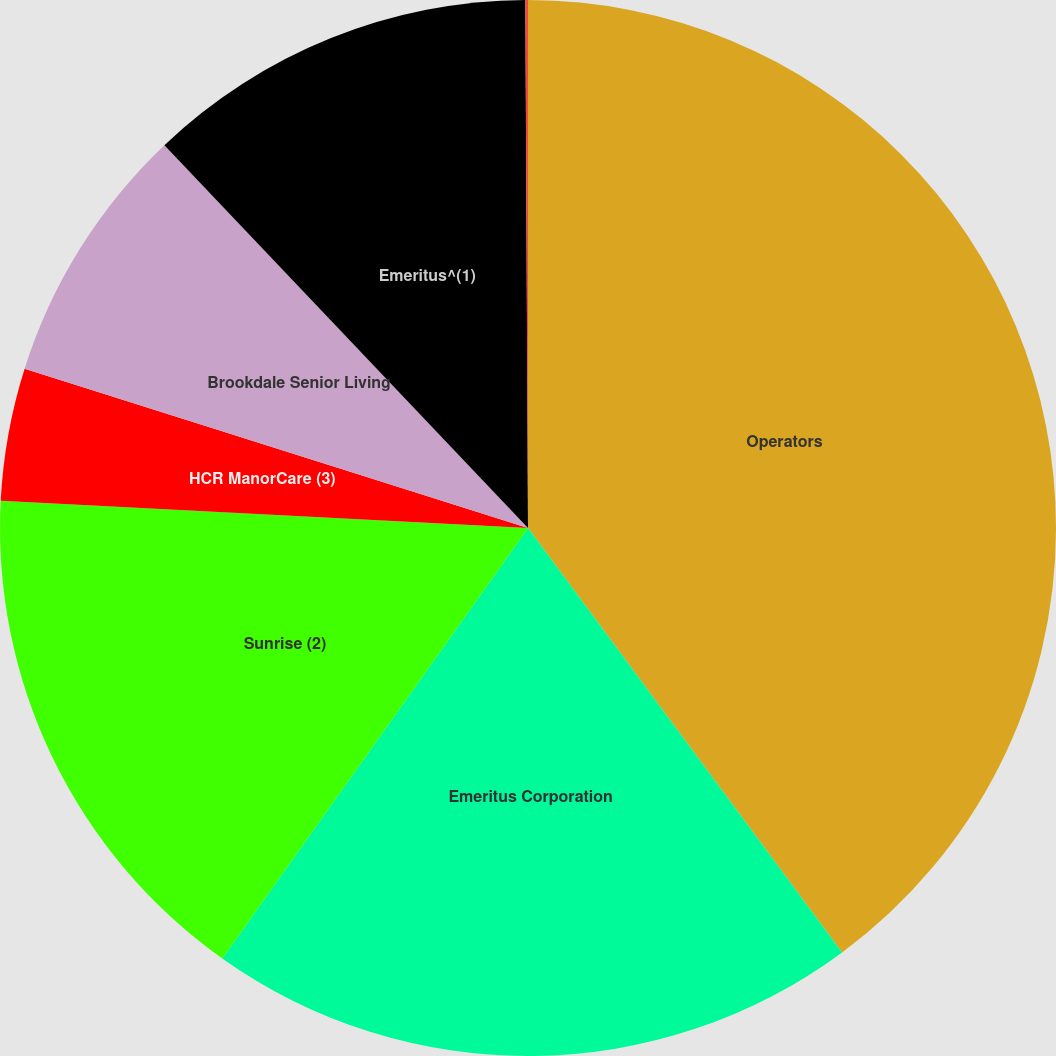Convert chart. <chart><loc_0><loc_0><loc_500><loc_500><pie_chart><fcel>Operators<fcel>Emeritus Corporation<fcel>Sunrise (2)<fcel>HCR ManorCare (3)<fcel>Brookdale Senior Living<fcel>Emeritus^(1)<fcel>Brookdale (4)<nl><fcel>39.86%<fcel>19.97%<fcel>15.99%<fcel>4.06%<fcel>8.03%<fcel>12.01%<fcel>0.08%<nl></chart> 